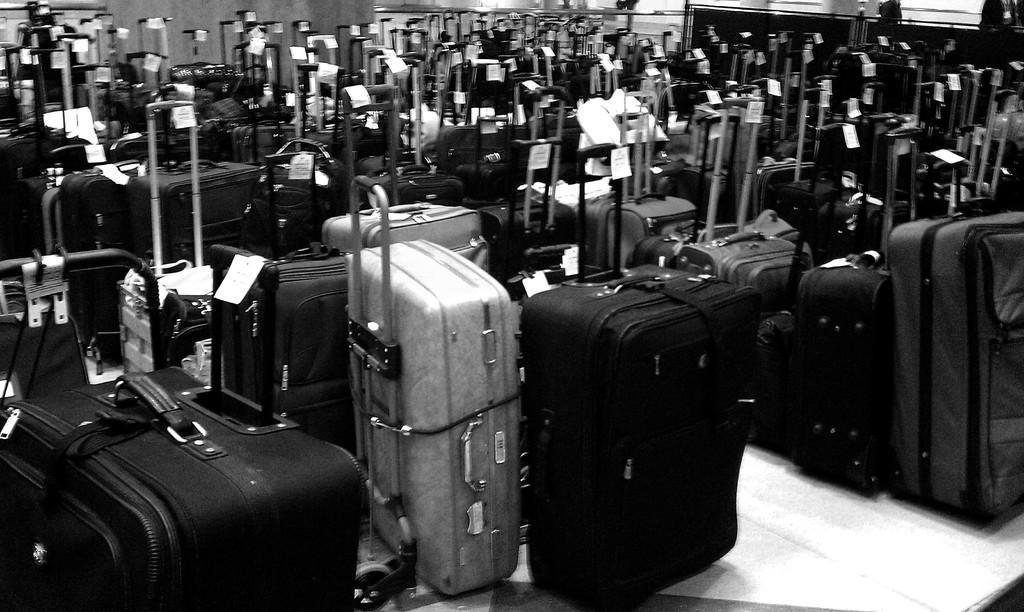Can you describe this image briefly? In the picture I can see some bags which are kept in a room. 